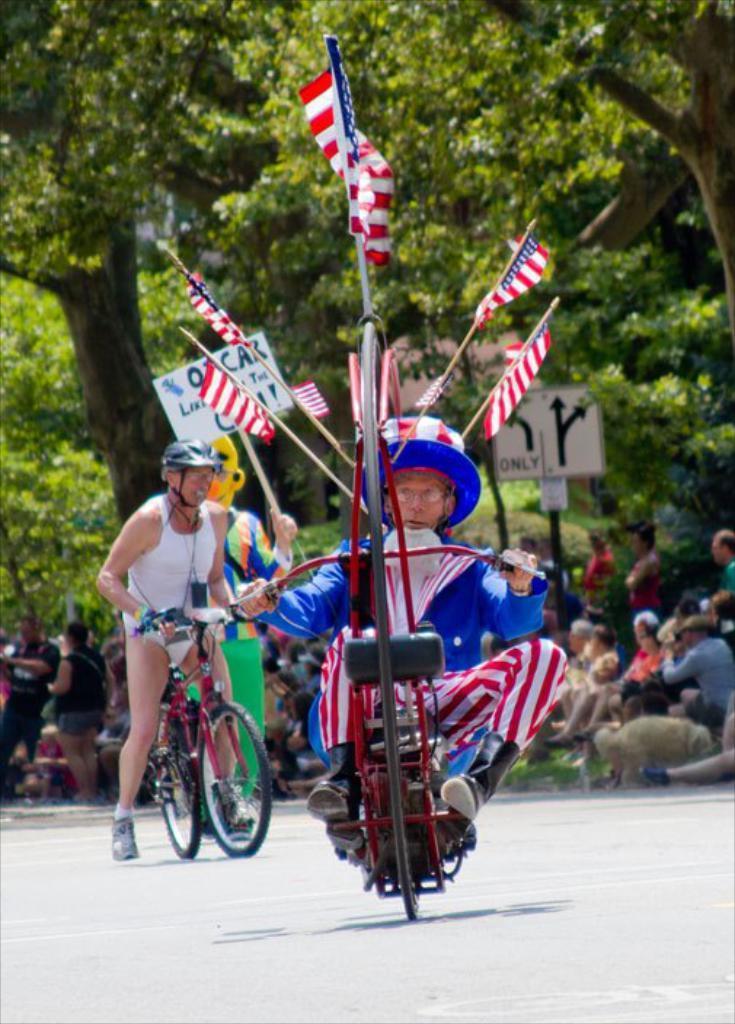Can you describe this image briefly? There are two persons,one is riding a vehicle and the other one is riding a bicycle. At background there are group of people sitting and watching. These are the trees and here I can see a sign board. 